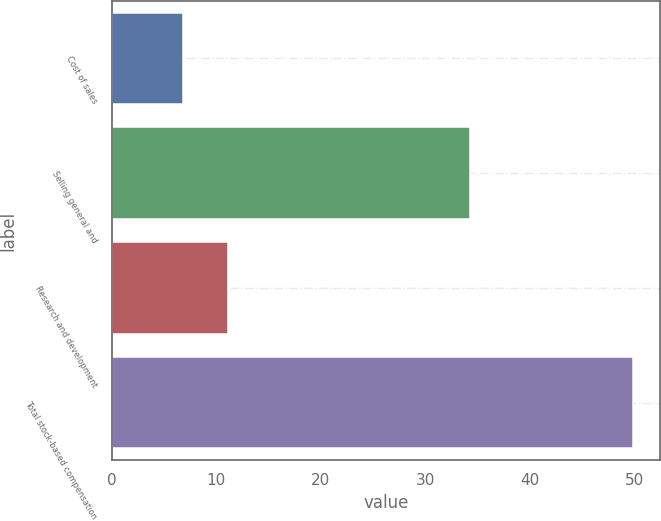Convert chart to OTSL. <chart><loc_0><loc_0><loc_500><loc_500><bar_chart><fcel>Cost of sales<fcel>Selling general and<fcel>Research and development<fcel>Total stock-based compensation<nl><fcel>6.8<fcel>34.3<fcel>11.11<fcel>49.9<nl></chart> 